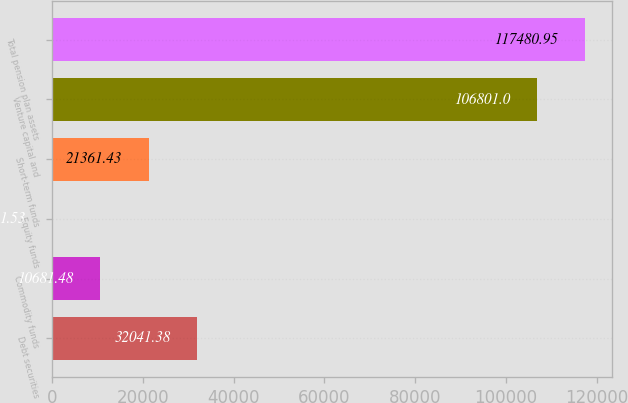<chart> <loc_0><loc_0><loc_500><loc_500><bar_chart><fcel>Debt securities<fcel>Commodity funds<fcel>Equity funds<fcel>Short-term funds<fcel>Venture capital and<fcel>Total pension plan assets<nl><fcel>32041.4<fcel>10681.5<fcel>1.53<fcel>21361.4<fcel>106801<fcel>117481<nl></chart> 